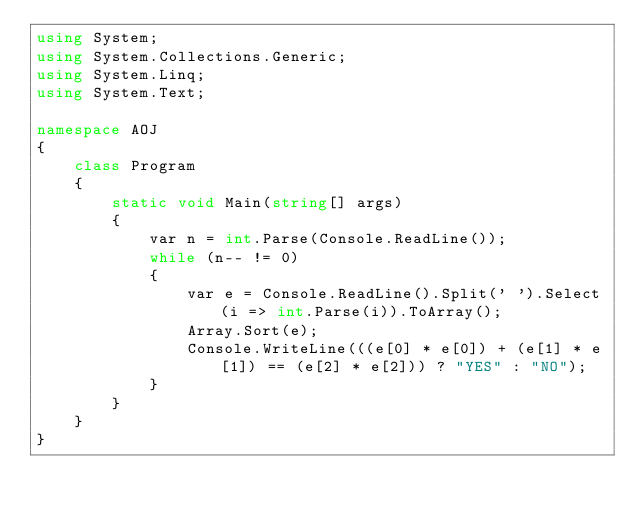Convert code to text. <code><loc_0><loc_0><loc_500><loc_500><_C#_>using System;
using System.Collections.Generic;
using System.Linq;
using System.Text;

namespace AOJ
{
	class Program
	{
		static void Main(string[] args)
		{
			var n = int.Parse(Console.ReadLine());
			while (n-- != 0)
			{
				var e = Console.ReadLine().Split(' ').Select(i => int.Parse(i)).ToArray();
				Array.Sort(e);
				Console.WriteLine(((e[0] * e[0]) + (e[1] * e[1]) == (e[2] * e[2])) ? "YES" : "NO");
			}
		}
	}
}</code> 